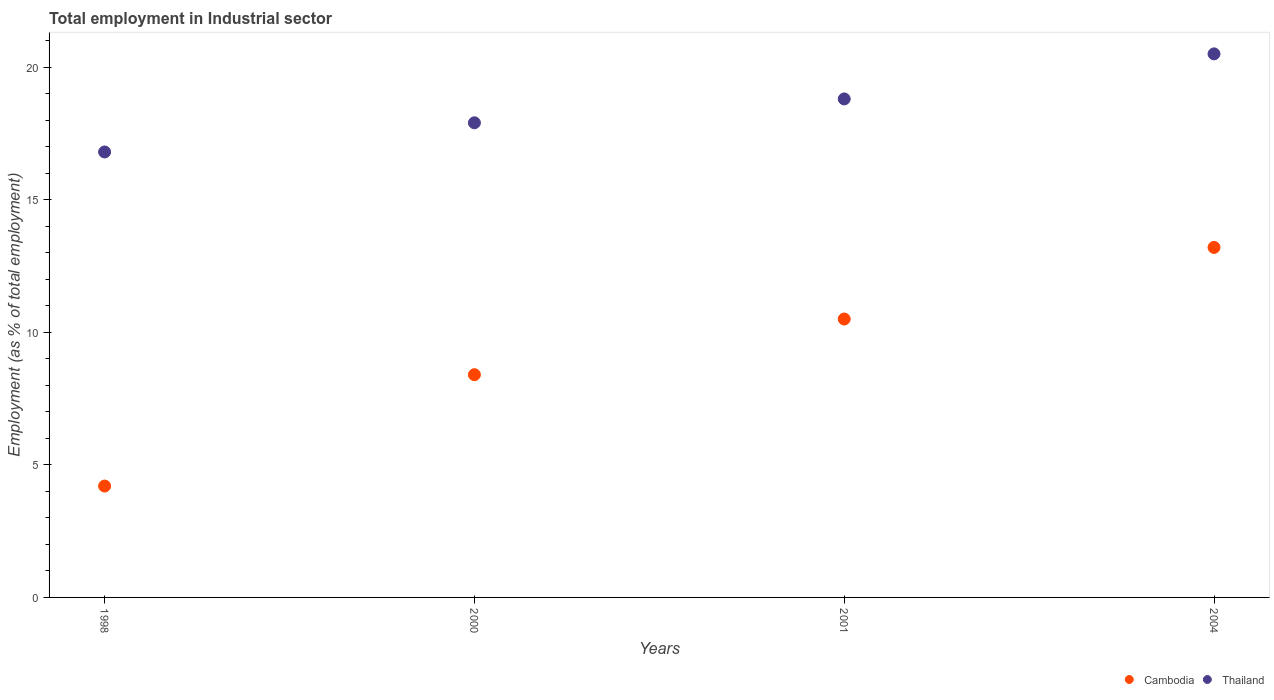How many different coloured dotlines are there?
Your answer should be very brief. 2. Is the number of dotlines equal to the number of legend labels?
Ensure brevity in your answer.  Yes. What is the employment in industrial sector in Thailand in 2001?
Keep it short and to the point. 18.8. Across all years, what is the maximum employment in industrial sector in Cambodia?
Provide a short and direct response. 13.2. Across all years, what is the minimum employment in industrial sector in Cambodia?
Your answer should be compact. 4.2. What is the total employment in industrial sector in Thailand in the graph?
Keep it short and to the point. 74. What is the difference between the employment in industrial sector in Cambodia in 1998 and that in 2001?
Give a very brief answer. -6.3. What is the difference between the employment in industrial sector in Cambodia in 2004 and the employment in industrial sector in Thailand in 2001?
Your response must be concise. -5.6. What is the average employment in industrial sector in Thailand per year?
Your answer should be compact. 18.5. In the year 2004, what is the difference between the employment in industrial sector in Cambodia and employment in industrial sector in Thailand?
Make the answer very short. -7.3. What is the ratio of the employment in industrial sector in Cambodia in 1998 to that in 2004?
Give a very brief answer. 0.32. Is the employment in industrial sector in Cambodia in 1998 less than that in 2004?
Make the answer very short. Yes. Is the difference between the employment in industrial sector in Cambodia in 1998 and 2000 greater than the difference between the employment in industrial sector in Thailand in 1998 and 2000?
Offer a terse response. No. What is the difference between the highest and the second highest employment in industrial sector in Cambodia?
Your answer should be very brief. 2.7. What is the difference between the highest and the lowest employment in industrial sector in Thailand?
Provide a succinct answer. 3.7. In how many years, is the employment in industrial sector in Cambodia greater than the average employment in industrial sector in Cambodia taken over all years?
Provide a succinct answer. 2. Is the employment in industrial sector in Cambodia strictly greater than the employment in industrial sector in Thailand over the years?
Make the answer very short. No. Is the employment in industrial sector in Thailand strictly less than the employment in industrial sector in Cambodia over the years?
Your answer should be compact. No. How many dotlines are there?
Ensure brevity in your answer.  2. How many years are there in the graph?
Keep it short and to the point. 4. Does the graph contain any zero values?
Provide a short and direct response. No. How many legend labels are there?
Offer a terse response. 2. How are the legend labels stacked?
Give a very brief answer. Horizontal. What is the title of the graph?
Give a very brief answer. Total employment in Industrial sector. What is the label or title of the X-axis?
Provide a short and direct response. Years. What is the label or title of the Y-axis?
Your answer should be compact. Employment (as % of total employment). What is the Employment (as % of total employment) of Cambodia in 1998?
Your response must be concise. 4.2. What is the Employment (as % of total employment) of Thailand in 1998?
Ensure brevity in your answer.  16.8. What is the Employment (as % of total employment) in Cambodia in 2000?
Provide a succinct answer. 8.4. What is the Employment (as % of total employment) of Thailand in 2000?
Keep it short and to the point. 17.9. What is the Employment (as % of total employment) in Cambodia in 2001?
Give a very brief answer. 10.5. What is the Employment (as % of total employment) of Thailand in 2001?
Provide a succinct answer. 18.8. What is the Employment (as % of total employment) in Cambodia in 2004?
Your response must be concise. 13.2. Across all years, what is the maximum Employment (as % of total employment) in Cambodia?
Your answer should be compact. 13.2. Across all years, what is the minimum Employment (as % of total employment) of Cambodia?
Provide a short and direct response. 4.2. Across all years, what is the minimum Employment (as % of total employment) in Thailand?
Your answer should be very brief. 16.8. What is the total Employment (as % of total employment) in Cambodia in the graph?
Your response must be concise. 36.3. What is the total Employment (as % of total employment) of Thailand in the graph?
Provide a succinct answer. 74. What is the difference between the Employment (as % of total employment) in Cambodia in 1998 and that in 2000?
Offer a terse response. -4.2. What is the difference between the Employment (as % of total employment) in Cambodia in 2000 and that in 2001?
Your response must be concise. -2.1. What is the difference between the Employment (as % of total employment) of Cambodia in 2000 and that in 2004?
Your answer should be compact. -4.8. What is the difference between the Employment (as % of total employment) of Cambodia in 2001 and that in 2004?
Make the answer very short. -2.7. What is the difference between the Employment (as % of total employment) in Thailand in 2001 and that in 2004?
Provide a succinct answer. -1.7. What is the difference between the Employment (as % of total employment) of Cambodia in 1998 and the Employment (as % of total employment) of Thailand in 2000?
Give a very brief answer. -13.7. What is the difference between the Employment (as % of total employment) in Cambodia in 1998 and the Employment (as % of total employment) in Thailand in 2001?
Offer a terse response. -14.6. What is the difference between the Employment (as % of total employment) in Cambodia in 1998 and the Employment (as % of total employment) in Thailand in 2004?
Ensure brevity in your answer.  -16.3. What is the difference between the Employment (as % of total employment) in Cambodia in 2000 and the Employment (as % of total employment) in Thailand in 2001?
Provide a short and direct response. -10.4. What is the difference between the Employment (as % of total employment) of Cambodia in 2000 and the Employment (as % of total employment) of Thailand in 2004?
Provide a succinct answer. -12.1. What is the difference between the Employment (as % of total employment) in Cambodia in 2001 and the Employment (as % of total employment) in Thailand in 2004?
Your response must be concise. -10. What is the average Employment (as % of total employment) of Cambodia per year?
Provide a short and direct response. 9.07. In the year 2001, what is the difference between the Employment (as % of total employment) in Cambodia and Employment (as % of total employment) in Thailand?
Offer a very short reply. -8.3. In the year 2004, what is the difference between the Employment (as % of total employment) of Cambodia and Employment (as % of total employment) of Thailand?
Give a very brief answer. -7.3. What is the ratio of the Employment (as % of total employment) in Thailand in 1998 to that in 2000?
Make the answer very short. 0.94. What is the ratio of the Employment (as % of total employment) of Cambodia in 1998 to that in 2001?
Your answer should be very brief. 0.4. What is the ratio of the Employment (as % of total employment) in Thailand in 1998 to that in 2001?
Offer a terse response. 0.89. What is the ratio of the Employment (as % of total employment) in Cambodia in 1998 to that in 2004?
Give a very brief answer. 0.32. What is the ratio of the Employment (as % of total employment) of Thailand in 1998 to that in 2004?
Offer a very short reply. 0.82. What is the ratio of the Employment (as % of total employment) of Cambodia in 2000 to that in 2001?
Ensure brevity in your answer.  0.8. What is the ratio of the Employment (as % of total employment) of Thailand in 2000 to that in 2001?
Your answer should be very brief. 0.95. What is the ratio of the Employment (as % of total employment) in Cambodia in 2000 to that in 2004?
Provide a succinct answer. 0.64. What is the ratio of the Employment (as % of total employment) in Thailand in 2000 to that in 2004?
Offer a very short reply. 0.87. What is the ratio of the Employment (as % of total employment) in Cambodia in 2001 to that in 2004?
Make the answer very short. 0.8. What is the ratio of the Employment (as % of total employment) in Thailand in 2001 to that in 2004?
Keep it short and to the point. 0.92. 